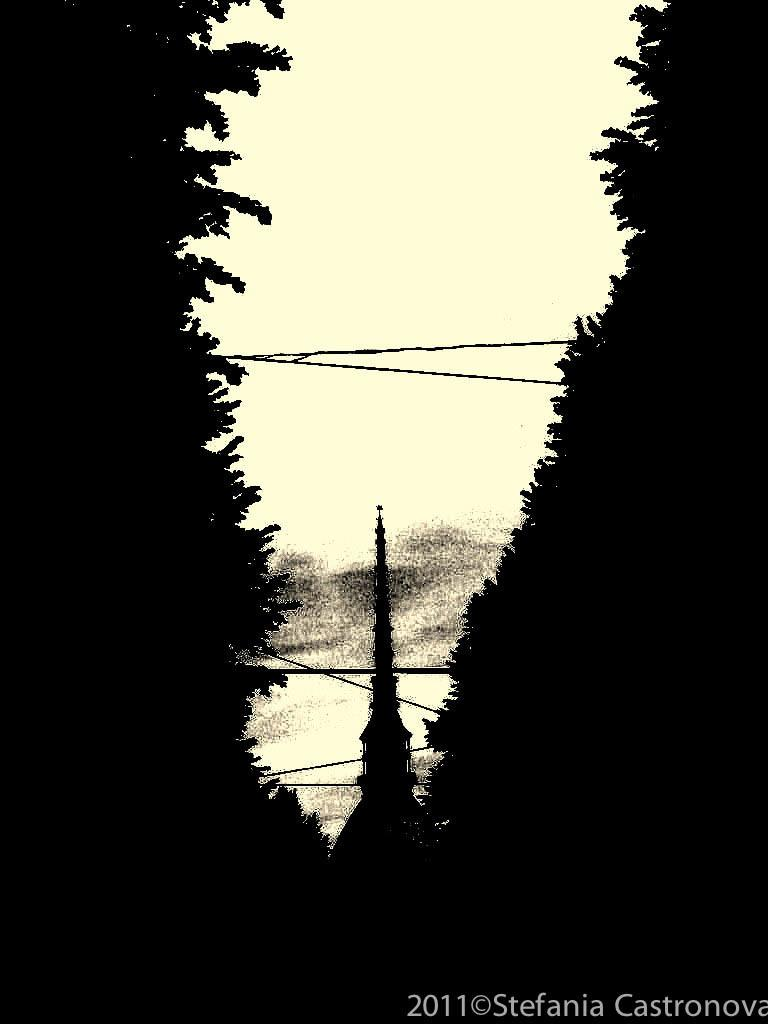What structure is located at the bottom of the image? There is a building at the bottom of the image. What type of vegetation can be seen on the right side of the image? There are trees on the right side of the image. What type of vegetation can be seen on the left side of the image? There are trees on the left side of the image. What is written or depicted at the bottom of the image? There is some text at the bottom of the image. What type of marble is used in the construction of the building in the image? There is no mention of marble in the image or the provided facts, so we cannot determine the type of marble used in the building's construction. 